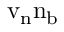<formula> <loc_0><loc_0><loc_500><loc_500>{ v } _ { n } { n } _ { b }</formula> 